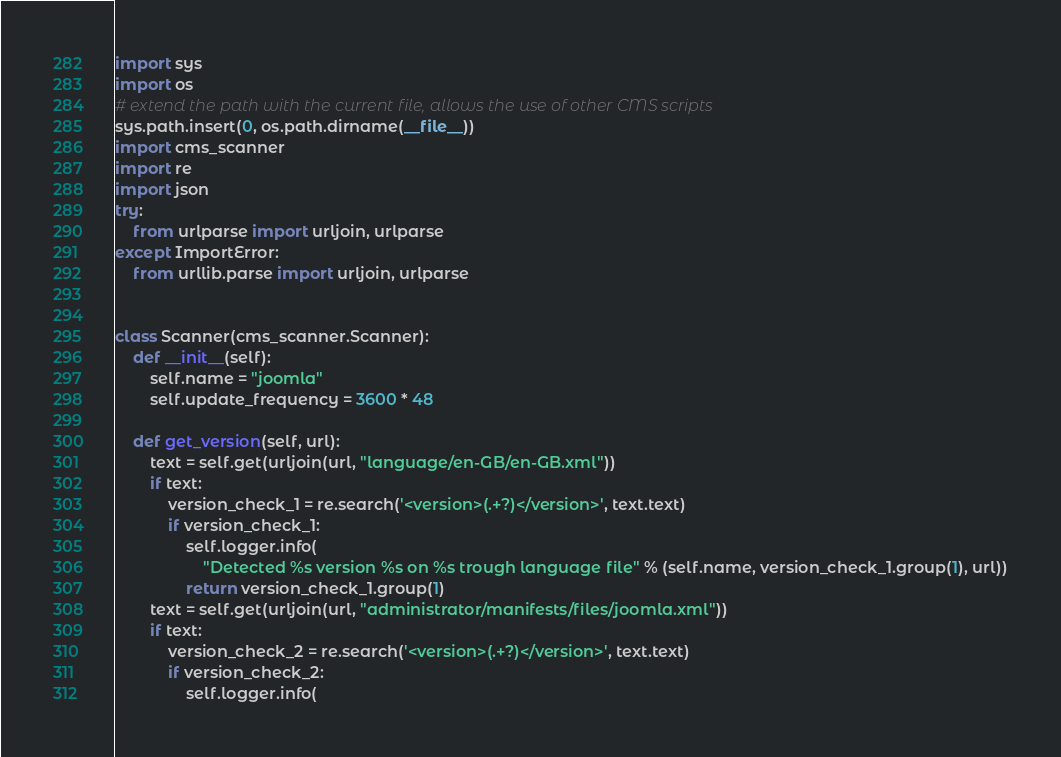<code> <loc_0><loc_0><loc_500><loc_500><_Python_>import sys
import os
# extend the path with the current file, allows the use of other CMS scripts
sys.path.insert(0, os.path.dirname(__file__))
import cms_scanner
import re
import json
try:
    from urlparse import urljoin, urlparse
except ImportError:
    from urllib.parse import urljoin, urlparse


class Scanner(cms_scanner.Scanner):
    def __init__(self):
        self.name = "joomla"
        self.update_frequency = 3600 * 48

    def get_version(self, url):
        text = self.get(urljoin(url, "language/en-GB/en-GB.xml"))
        if text:
            version_check_1 = re.search('<version>(.+?)</version>', text.text)
            if version_check_1:
                self.logger.info(
                    "Detected %s version %s on %s trough language file" % (self.name, version_check_1.group(1), url))
                return version_check_1.group(1)
        text = self.get(urljoin(url, "administrator/manifests/files/joomla.xml"))
        if text:
            version_check_2 = re.search('<version>(.+?)</version>', text.text)
            if version_check_2:
                self.logger.info(</code> 